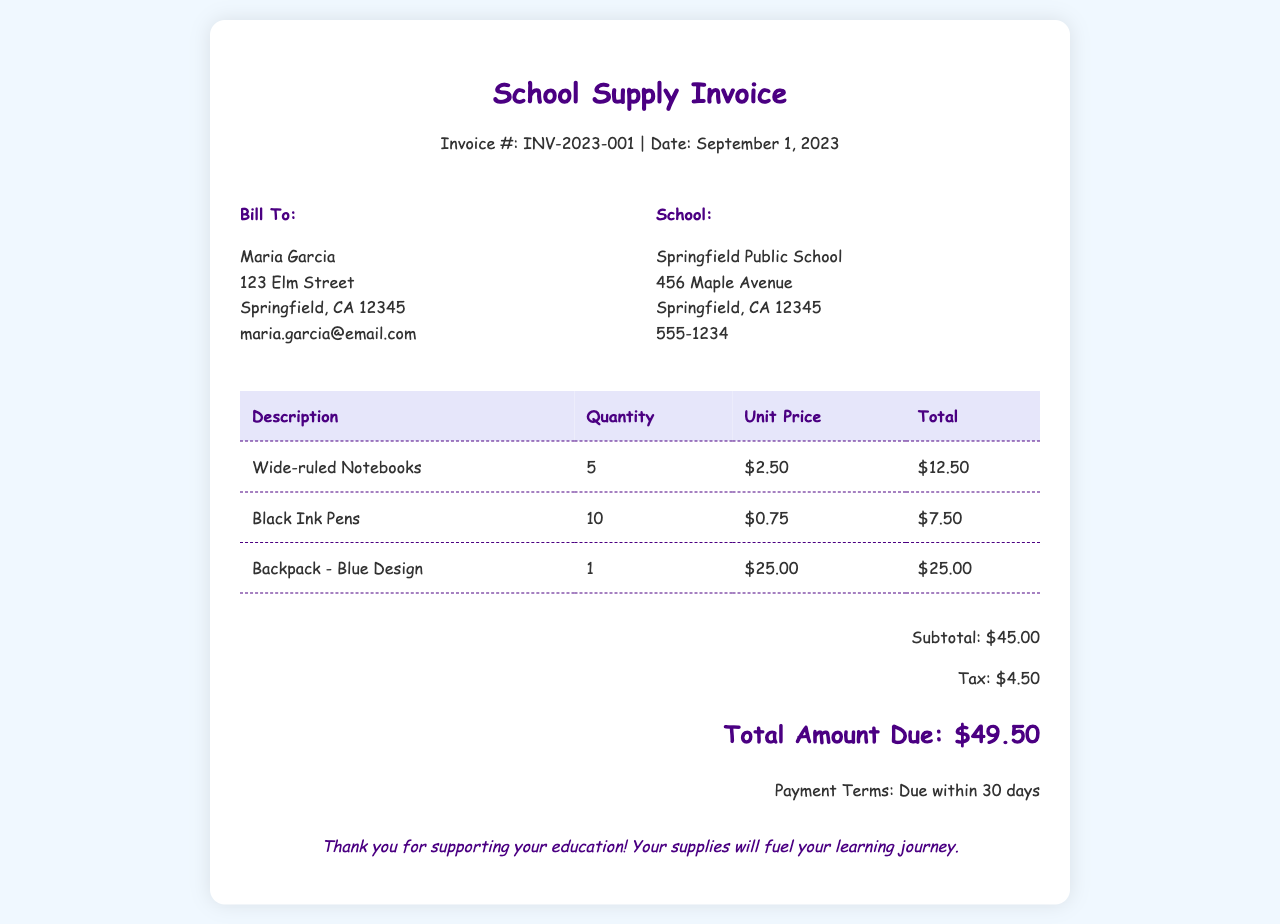What is the invoice number? The invoice number is located at the top of the document, following the title.
Answer: INV-2023-001 What is the date of the invoice? The date is specified right after the invoice number in the header.
Answer: September 1, 2023 Who is the bill to? The "Bill To" section lists the name of the person being billed.
Answer: Maria Garcia What is the total amount due? The total amount due is highlighted in the total section of the invoice.
Answer: $49.50 How many wide-ruled notebooks were purchased? The quantity is listed in the table under the notebook description.
Answer: 5 What is the subtotal of the items? The subtotal appears towards the end of the invoice, before tax is added.
Answer: $45.00 What is the tax amount charged? The tax amount is specified in the total section right after the subtotal.
Answer: $4.50 What type of backpack was purchased? The description of the backpack is provided in the table under backpack item.
Answer: Blue Design What are the payment terms? The payment terms are provided at the end of the invoice summary.
Answer: Due within 30 days 